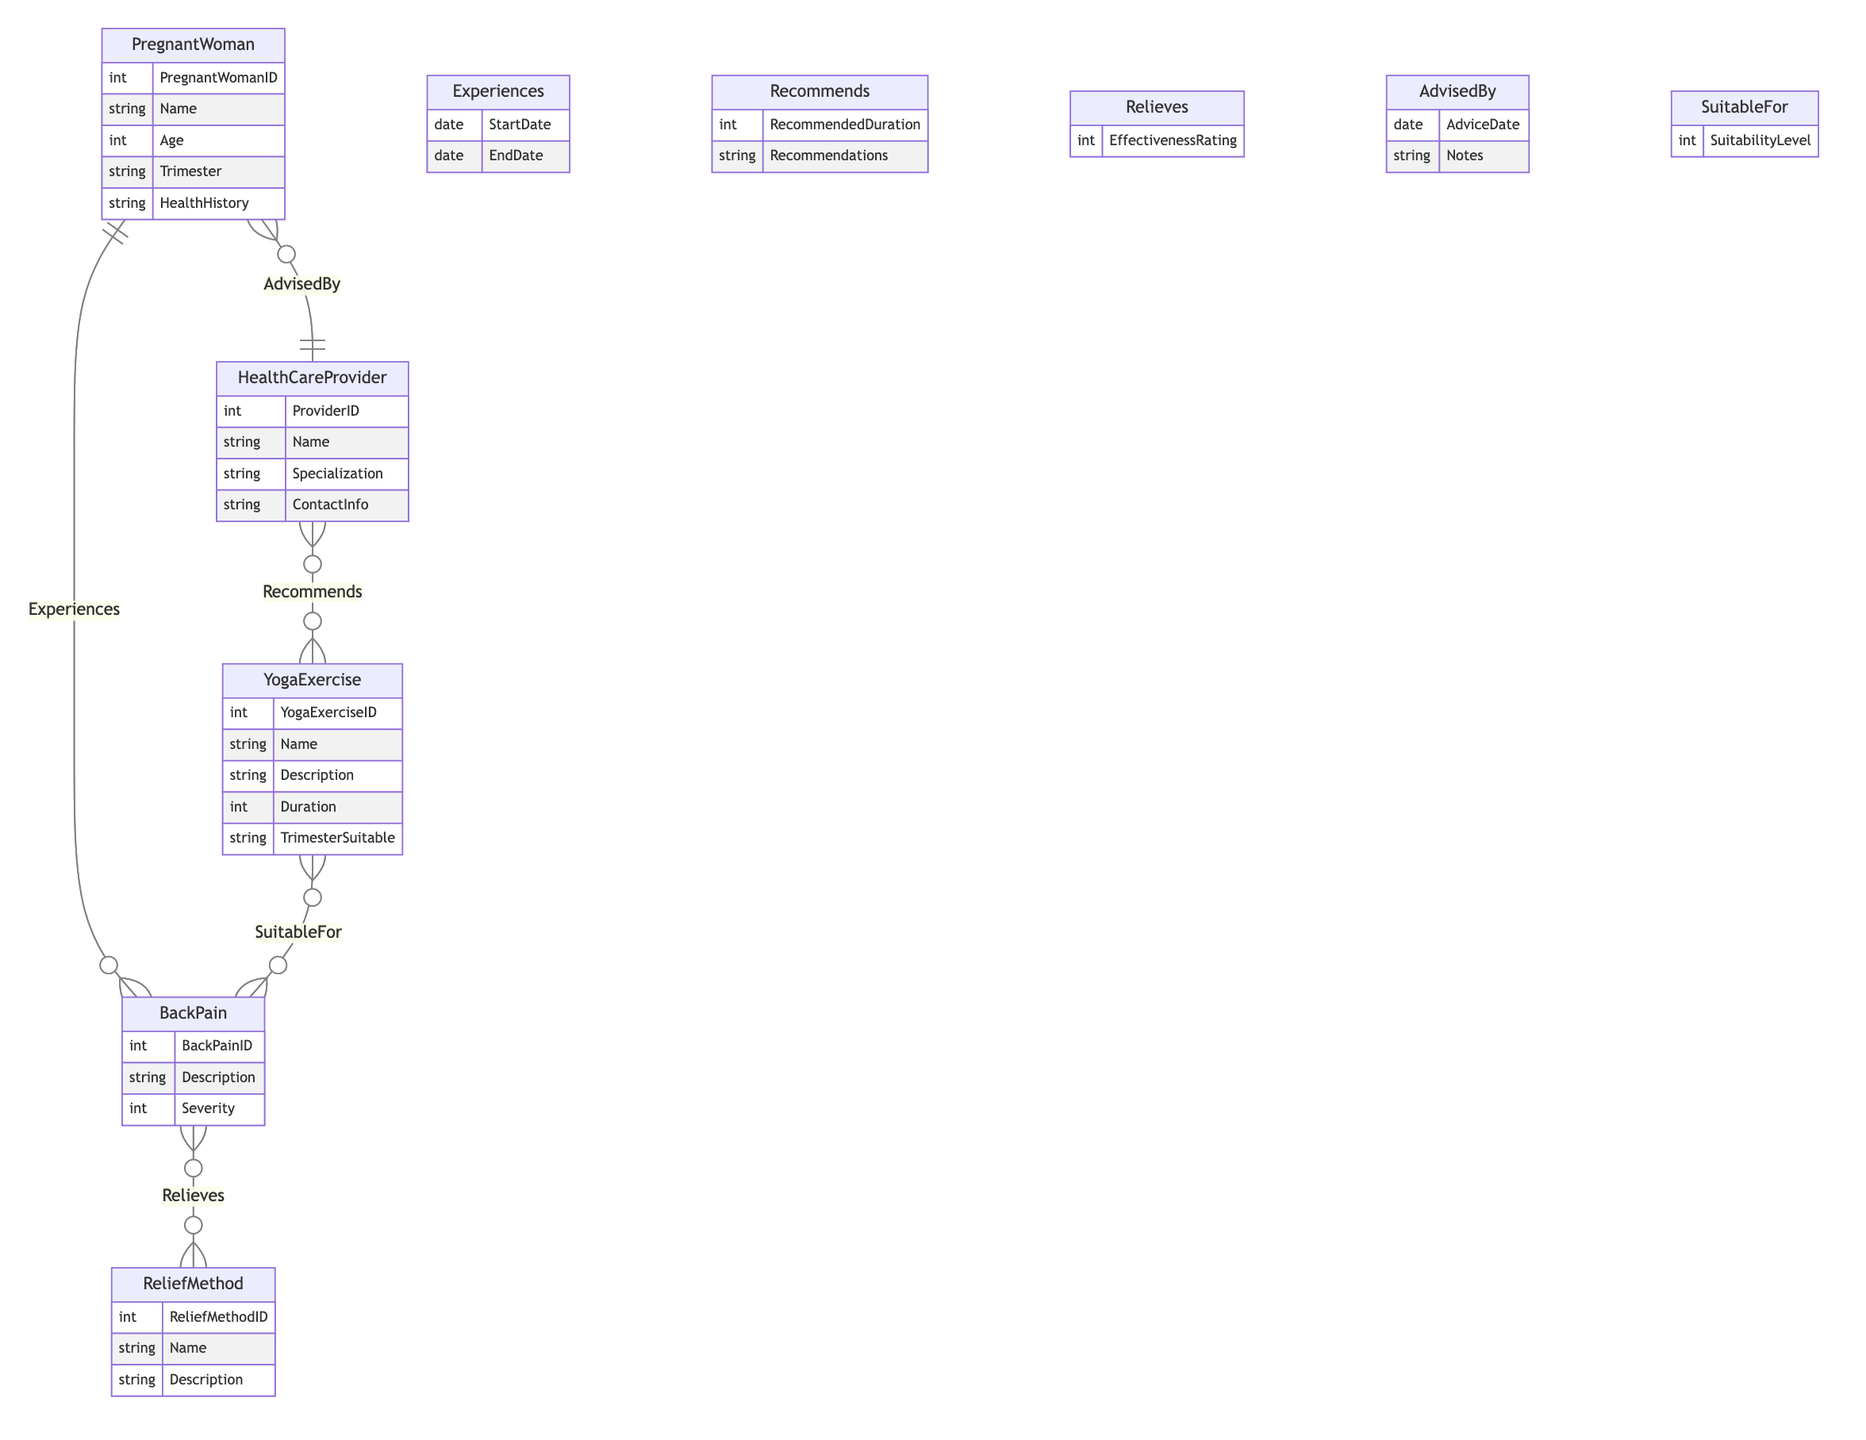What is the maximum number of BackPain instances a PregnantWoman can experience? The relationship between PregnantWoman and BackPain is defined as 1-to-Many, indicating that a single PregnantWoman may experience multiple instances of BackPain.
Answer: Many How many attributes are in the ReliefMethod entity? The ReliefMethod entity has three attributes: ReliefMethodID, Name, and Description. Counting these gives a total of 3 attributes.
Answer: 3 What is the relationship name between HealthCareProvider and YogaExercise? The relationship between HealthCareProvider and YogaExercise is named "Recommends". This term indicates that HealthCare Providers make suggestions regarding Yoga Exercises.
Answer: Recommends What attribute is shared in the relationship between PregnantWoman and HealthCareProvider? The shared attribute in the relationship AdvisedBy between PregnantWoman and HealthCareProvider is "Notes". This indicates that some notes may be attached to the advice given by providers.
Answer: Notes How many entities are involved in the Provides relationship? The Provides relationship connects two entities: HealthCareProvider and ReliefMethod. Thus the answer is 2 entities.
Answer: 2 Which entity details the description of back pain? The BackPain entity includes an attribute called "Description" which specifically details the nature of back pain experienced by the pregnant woman.
Answer: BackPain What is the cardinality of the relationship between YogaExercise and BackPain? The relationship between YogaExercise and BackPain is represented as Many-to-Many, meaning multiple types of YogaExercise can be suitable for several instances of BackPain.
Answer: Many-to-Many What attribute indicates the effectiveness of a ReliefMethod? The ReliefMethod entity contains the attribute named "EffectivenessRating", which is specifically meant to indicate how effective each method is in alleviating pain.
Answer: EffectivenessRating How many attributes are in the YogaExercise entity? The YogaExercise entity has five attributes: YogaExerciseID, Name, Description, Duration, and TrimesterSuitable. Thus, there are 5 attributes in total.
Answer: 5 